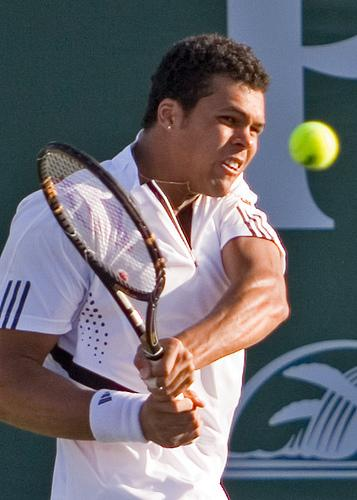This playing is making what shot? Please explain your reasoning. backhand. Tennis players make this movement when making a swing across his/her body. 